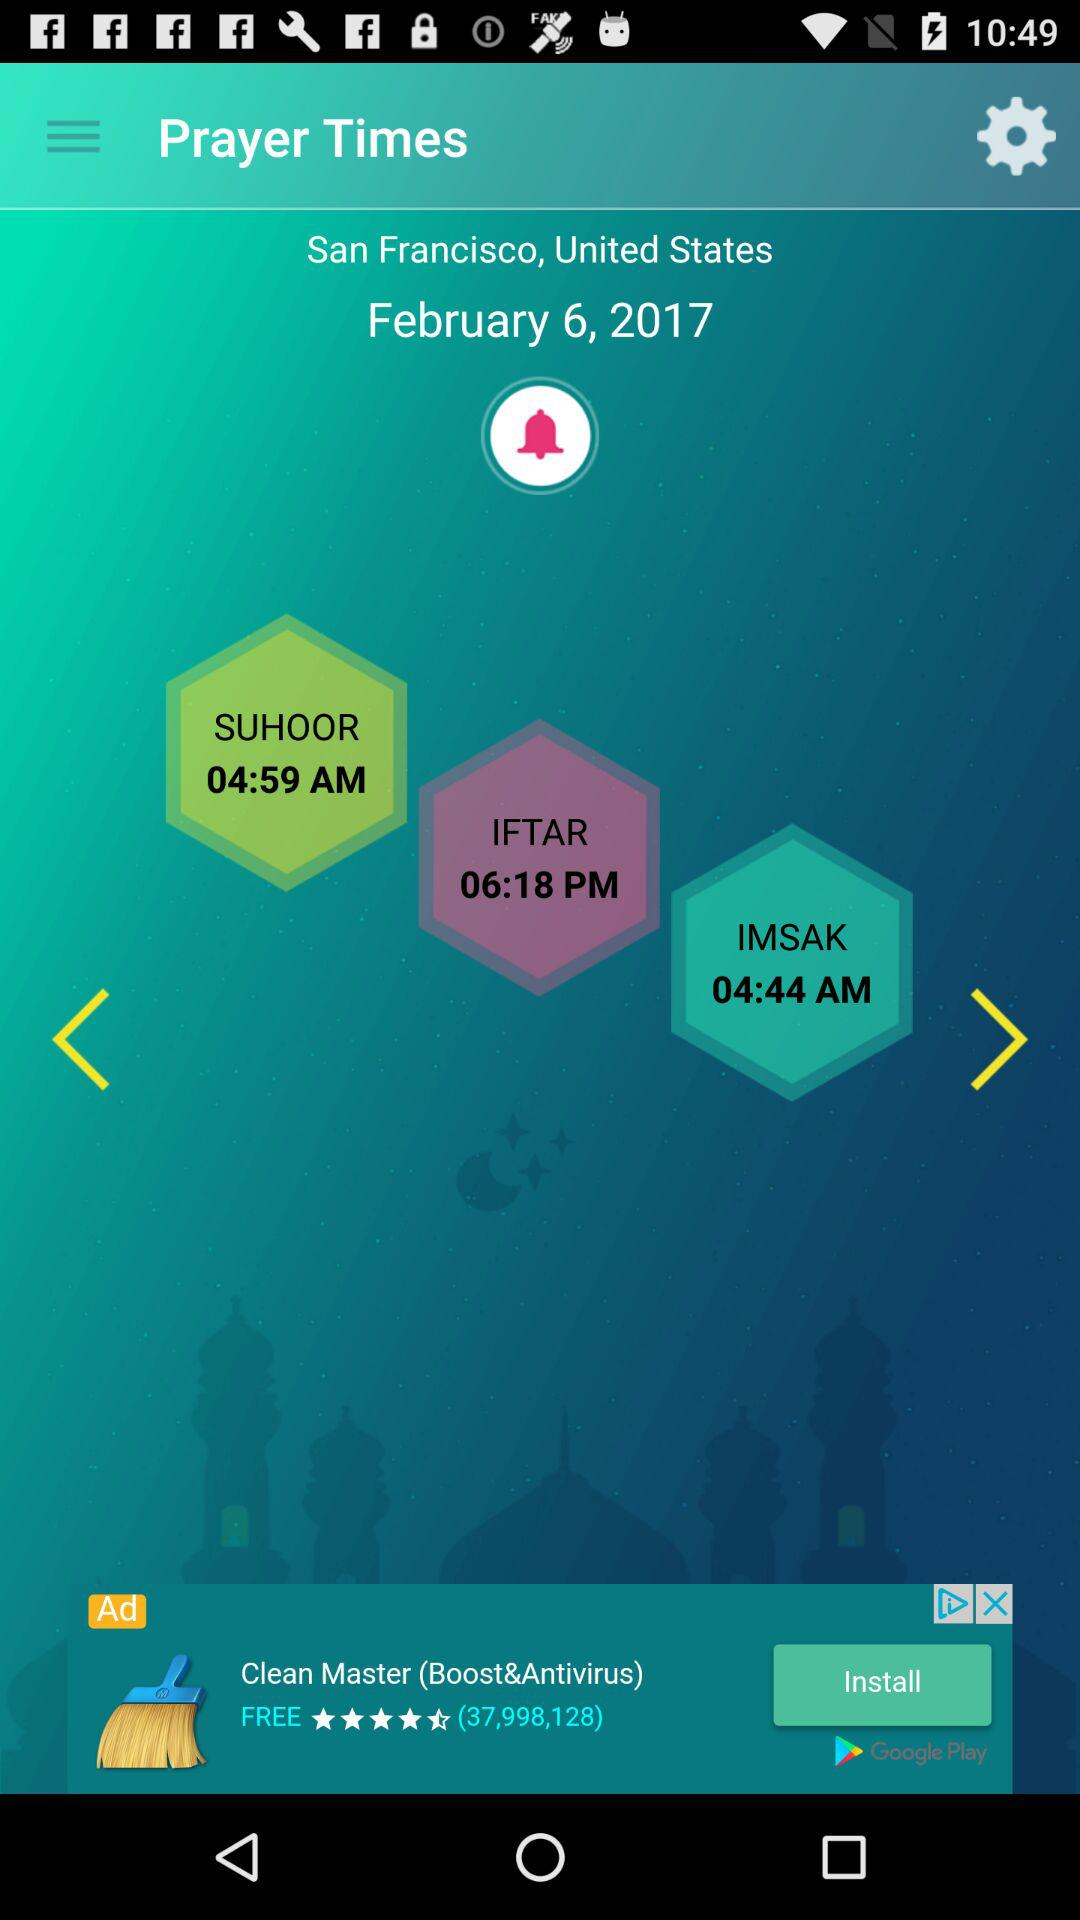What is the time of the "IFTAR" prayer? The time of the "IFTAR" prayer is 6:18 PM. 